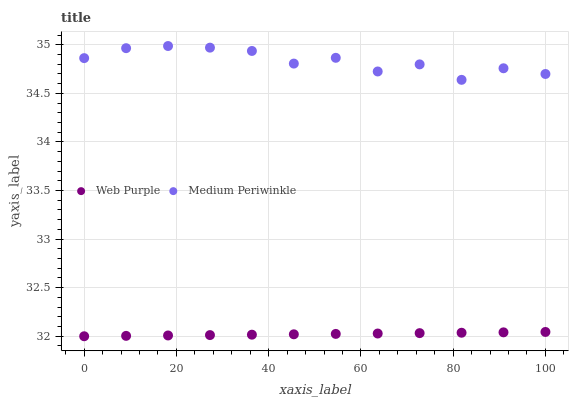Does Web Purple have the minimum area under the curve?
Answer yes or no. Yes. Does Medium Periwinkle have the maximum area under the curve?
Answer yes or no. Yes. Does Medium Periwinkle have the minimum area under the curve?
Answer yes or no. No. Is Web Purple the smoothest?
Answer yes or no. Yes. Is Medium Periwinkle the roughest?
Answer yes or no. Yes. Is Medium Periwinkle the smoothest?
Answer yes or no. No. Does Web Purple have the lowest value?
Answer yes or no. Yes. Does Medium Periwinkle have the lowest value?
Answer yes or no. No. Does Medium Periwinkle have the highest value?
Answer yes or no. Yes. Is Web Purple less than Medium Periwinkle?
Answer yes or no. Yes. Is Medium Periwinkle greater than Web Purple?
Answer yes or no. Yes. Does Web Purple intersect Medium Periwinkle?
Answer yes or no. No. 